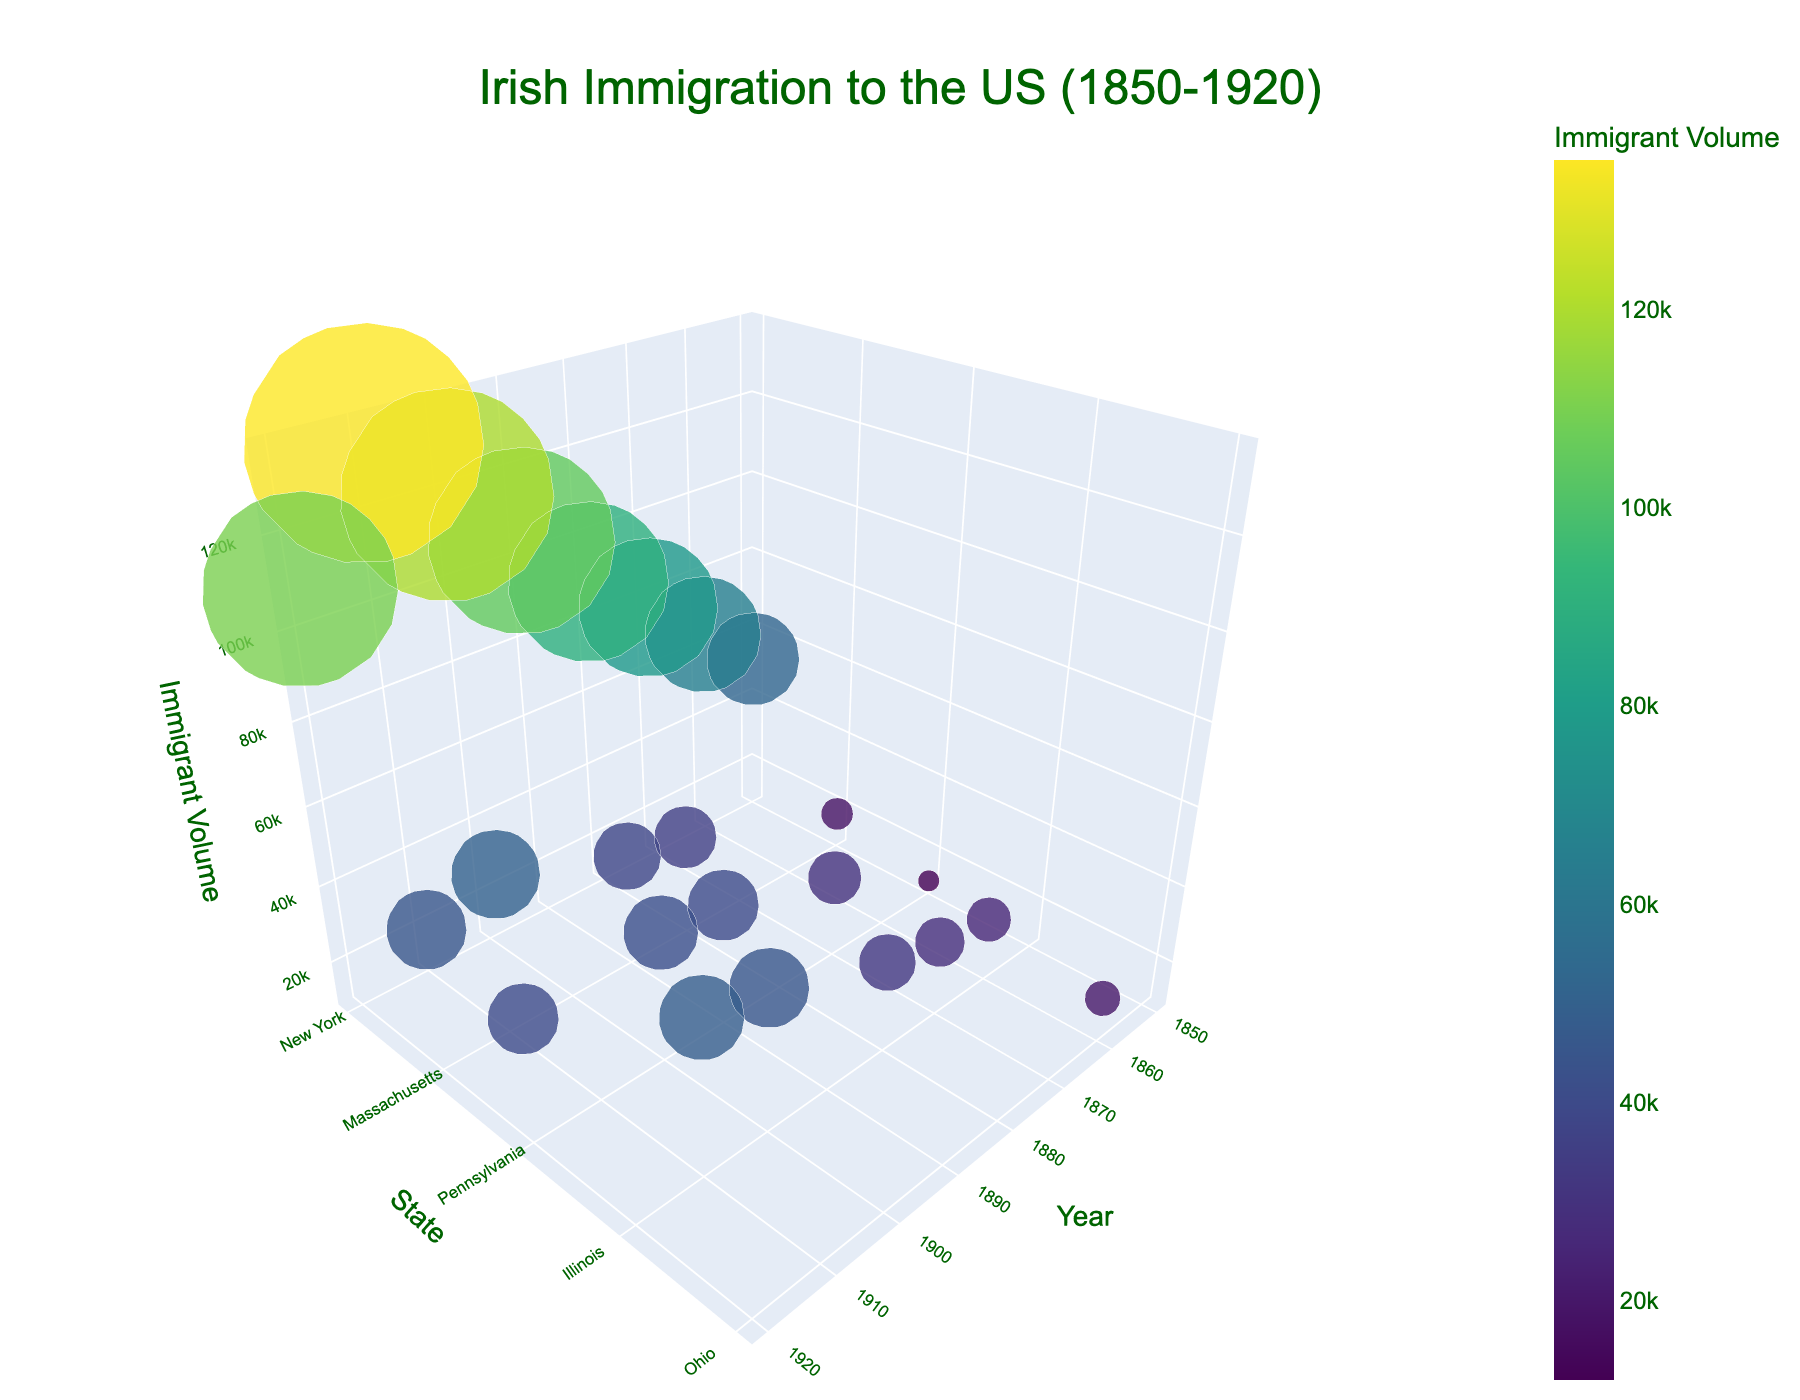What is the title of the figure? The title is typically displayed prominently at the top of the figure. It reads as 'Irish Immigration to the US (1850-1920)'.
Answer: Irish Immigration to the US (1850-1920) Which year has the highest immigrant volume from Ireland to the US for New York? To find this, look at the data points for New York and compare the z-axis values (Immigrant Volume) across different years. The highest volume is observed in 1910.
Answer: 1910 What is the total immigrant volume for Massachusetts in the year 1880? Locate the data point for Massachusetts in 1880 and read the immigrant volume from the z-axis. The value is 35,000.
Answer: 35,000 How does the immigrant volume in Illinois in 1860 compare to the volume in 1900? Compare the z-values of Illinois in 1860 and 1900. In 1860, it's 25,000, and in 1900, it's 45,000. The volume in 1900 is higher.
Answer: 1900 is higher Which state had the lowest immigrant volume in 1850? Identify the data points for the year 1850 and compare the z-values. Pennsylvania had the lowest volume at 12,000.
Answer: Pennsylvania What is the trend in immigrant volume for New York from 1850 to 1920? Observe the line of data points for New York over the years and note the changes in volume. The volume generally increases from 52,000 in 1850 to a peak at 135,000 in 1910, then decreases to 110,000 in 1920.
Answer: Generally increasing, peaking in 1910, then decreasing How many states had an immigrant volume of 40,000 or more in 1890? Find and count the data points for the year 1890 with z-values of 40,000 or more. New York, Pennsylvania, and Massachusetts meet this criterion.
Answer: 3 states What's the average immigrant volume in Pennsylvania for the available years? Sum the immigrant volumes for Pennsylvania and divide by the number of data points. (12,000 + 30,000 + 40,000 + 42,000 + 40,000) / 5 = 32,800
Answer: 32,800 Was Massachusetts' immigrant volume ever higher than Illinois' during the period? Compare the Massachusetts and Illinois data points for each year. Yes, in 1910, Massachusetts had 50,000 while Illinois had 48,000.
Answer: Yes What’s the overall trend in immigrant volume to Pennsylvania from 1850 to 1920? Look at Pennsylvania's data points and note how the immigrant volume changes over time. It increases steadily from 12,000 in 1850 to 42,000 in 1900, then slightly decreases to 40,000 in 1920.
Answer: Generally increasing, with a slight decrease after 1900 